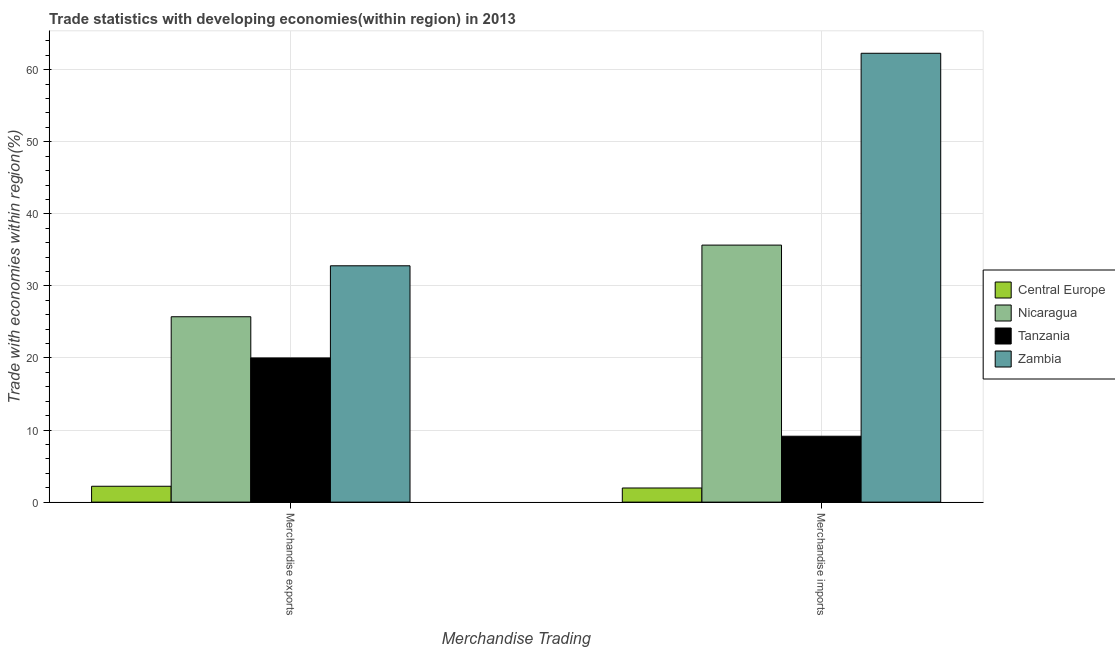Are the number of bars per tick equal to the number of legend labels?
Make the answer very short. Yes. How many bars are there on the 2nd tick from the right?
Your answer should be compact. 4. What is the label of the 2nd group of bars from the left?
Keep it short and to the point. Merchandise imports. What is the merchandise exports in Nicaragua?
Your response must be concise. 25.72. Across all countries, what is the maximum merchandise imports?
Keep it short and to the point. 62.28. Across all countries, what is the minimum merchandise imports?
Your answer should be compact. 1.96. In which country was the merchandise imports maximum?
Give a very brief answer. Zambia. In which country was the merchandise imports minimum?
Your response must be concise. Central Europe. What is the total merchandise exports in the graph?
Your response must be concise. 80.73. What is the difference between the merchandise imports in Nicaragua and that in Central Europe?
Offer a terse response. 33.7. What is the difference between the merchandise exports in Zambia and the merchandise imports in Nicaragua?
Offer a terse response. -2.87. What is the average merchandise exports per country?
Ensure brevity in your answer.  20.18. What is the difference between the merchandise imports and merchandise exports in Nicaragua?
Make the answer very short. 9.94. What is the ratio of the merchandise exports in Nicaragua to that in Tanzania?
Your response must be concise. 1.29. In how many countries, is the merchandise exports greater than the average merchandise exports taken over all countries?
Offer a very short reply. 2. What does the 2nd bar from the left in Merchandise imports represents?
Your answer should be very brief. Nicaragua. What does the 2nd bar from the right in Merchandise imports represents?
Your answer should be very brief. Tanzania. How many bars are there?
Your answer should be very brief. 8. Are all the bars in the graph horizontal?
Make the answer very short. No. Are the values on the major ticks of Y-axis written in scientific E-notation?
Offer a very short reply. No. Does the graph contain grids?
Make the answer very short. Yes. Where does the legend appear in the graph?
Provide a short and direct response. Center right. What is the title of the graph?
Give a very brief answer. Trade statistics with developing economies(within region) in 2013. Does "Cuba" appear as one of the legend labels in the graph?
Keep it short and to the point. No. What is the label or title of the X-axis?
Your answer should be very brief. Merchandise Trading. What is the label or title of the Y-axis?
Your answer should be very brief. Trade with economies within region(%). What is the Trade with economies within region(%) of Central Europe in Merchandise exports?
Ensure brevity in your answer.  2.2. What is the Trade with economies within region(%) in Nicaragua in Merchandise exports?
Provide a succinct answer. 25.72. What is the Trade with economies within region(%) in Tanzania in Merchandise exports?
Give a very brief answer. 20.01. What is the Trade with economies within region(%) of Zambia in Merchandise exports?
Ensure brevity in your answer.  32.8. What is the Trade with economies within region(%) in Central Europe in Merchandise imports?
Offer a terse response. 1.96. What is the Trade with economies within region(%) in Nicaragua in Merchandise imports?
Provide a succinct answer. 35.67. What is the Trade with economies within region(%) of Tanzania in Merchandise imports?
Your response must be concise. 9.15. What is the Trade with economies within region(%) in Zambia in Merchandise imports?
Provide a short and direct response. 62.28. Across all Merchandise Trading, what is the maximum Trade with economies within region(%) of Central Europe?
Ensure brevity in your answer.  2.2. Across all Merchandise Trading, what is the maximum Trade with economies within region(%) of Nicaragua?
Provide a short and direct response. 35.67. Across all Merchandise Trading, what is the maximum Trade with economies within region(%) of Tanzania?
Give a very brief answer. 20.01. Across all Merchandise Trading, what is the maximum Trade with economies within region(%) in Zambia?
Make the answer very short. 62.28. Across all Merchandise Trading, what is the minimum Trade with economies within region(%) of Central Europe?
Ensure brevity in your answer.  1.96. Across all Merchandise Trading, what is the minimum Trade with economies within region(%) in Nicaragua?
Your answer should be compact. 25.72. Across all Merchandise Trading, what is the minimum Trade with economies within region(%) of Tanzania?
Your response must be concise. 9.15. Across all Merchandise Trading, what is the minimum Trade with economies within region(%) of Zambia?
Make the answer very short. 32.8. What is the total Trade with economies within region(%) of Central Europe in the graph?
Offer a very short reply. 4.16. What is the total Trade with economies within region(%) in Nicaragua in the graph?
Offer a very short reply. 61.39. What is the total Trade with economies within region(%) of Tanzania in the graph?
Offer a terse response. 29.15. What is the total Trade with economies within region(%) of Zambia in the graph?
Your response must be concise. 95.08. What is the difference between the Trade with economies within region(%) in Central Europe in Merchandise exports and that in Merchandise imports?
Your response must be concise. 0.24. What is the difference between the Trade with economies within region(%) in Nicaragua in Merchandise exports and that in Merchandise imports?
Your response must be concise. -9.94. What is the difference between the Trade with economies within region(%) of Tanzania in Merchandise exports and that in Merchandise imports?
Make the answer very short. 10.86. What is the difference between the Trade with economies within region(%) in Zambia in Merchandise exports and that in Merchandise imports?
Your answer should be very brief. -29.49. What is the difference between the Trade with economies within region(%) of Central Europe in Merchandise exports and the Trade with economies within region(%) of Nicaragua in Merchandise imports?
Provide a succinct answer. -33.46. What is the difference between the Trade with economies within region(%) of Central Europe in Merchandise exports and the Trade with economies within region(%) of Tanzania in Merchandise imports?
Offer a terse response. -6.94. What is the difference between the Trade with economies within region(%) of Central Europe in Merchandise exports and the Trade with economies within region(%) of Zambia in Merchandise imports?
Provide a succinct answer. -60.08. What is the difference between the Trade with economies within region(%) in Nicaragua in Merchandise exports and the Trade with economies within region(%) in Tanzania in Merchandise imports?
Offer a very short reply. 16.58. What is the difference between the Trade with economies within region(%) of Nicaragua in Merchandise exports and the Trade with economies within region(%) of Zambia in Merchandise imports?
Ensure brevity in your answer.  -36.56. What is the difference between the Trade with economies within region(%) in Tanzania in Merchandise exports and the Trade with economies within region(%) in Zambia in Merchandise imports?
Provide a succinct answer. -42.27. What is the average Trade with economies within region(%) of Central Europe per Merchandise Trading?
Offer a very short reply. 2.08. What is the average Trade with economies within region(%) of Nicaragua per Merchandise Trading?
Your answer should be compact. 30.69. What is the average Trade with economies within region(%) in Tanzania per Merchandise Trading?
Offer a terse response. 14.58. What is the average Trade with economies within region(%) of Zambia per Merchandise Trading?
Offer a terse response. 47.54. What is the difference between the Trade with economies within region(%) in Central Europe and Trade with economies within region(%) in Nicaragua in Merchandise exports?
Make the answer very short. -23.52. What is the difference between the Trade with economies within region(%) of Central Europe and Trade with economies within region(%) of Tanzania in Merchandise exports?
Provide a succinct answer. -17.81. What is the difference between the Trade with economies within region(%) of Central Europe and Trade with economies within region(%) of Zambia in Merchandise exports?
Offer a very short reply. -30.59. What is the difference between the Trade with economies within region(%) of Nicaragua and Trade with economies within region(%) of Tanzania in Merchandise exports?
Your answer should be compact. 5.71. What is the difference between the Trade with economies within region(%) in Nicaragua and Trade with economies within region(%) in Zambia in Merchandise exports?
Keep it short and to the point. -7.07. What is the difference between the Trade with economies within region(%) of Tanzania and Trade with economies within region(%) of Zambia in Merchandise exports?
Provide a short and direct response. -12.79. What is the difference between the Trade with economies within region(%) of Central Europe and Trade with economies within region(%) of Nicaragua in Merchandise imports?
Make the answer very short. -33.7. What is the difference between the Trade with economies within region(%) in Central Europe and Trade with economies within region(%) in Tanzania in Merchandise imports?
Provide a succinct answer. -7.18. What is the difference between the Trade with economies within region(%) in Central Europe and Trade with economies within region(%) in Zambia in Merchandise imports?
Make the answer very short. -60.32. What is the difference between the Trade with economies within region(%) of Nicaragua and Trade with economies within region(%) of Tanzania in Merchandise imports?
Provide a succinct answer. 26.52. What is the difference between the Trade with economies within region(%) of Nicaragua and Trade with economies within region(%) of Zambia in Merchandise imports?
Your answer should be compact. -26.62. What is the difference between the Trade with economies within region(%) in Tanzania and Trade with economies within region(%) in Zambia in Merchandise imports?
Offer a very short reply. -53.14. What is the ratio of the Trade with economies within region(%) in Central Europe in Merchandise exports to that in Merchandise imports?
Ensure brevity in your answer.  1.12. What is the ratio of the Trade with economies within region(%) of Nicaragua in Merchandise exports to that in Merchandise imports?
Provide a succinct answer. 0.72. What is the ratio of the Trade with economies within region(%) in Tanzania in Merchandise exports to that in Merchandise imports?
Your response must be concise. 2.19. What is the ratio of the Trade with economies within region(%) of Zambia in Merchandise exports to that in Merchandise imports?
Make the answer very short. 0.53. What is the difference between the highest and the second highest Trade with economies within region(%) in Central Europe?
Your answer should be very brief. 0.24. What is the difference between the highest and the second highest Trade with economies within region(%) in Nicaragua?
Make the answer very short. 9.94. What is the difference between the highest and the second highest Trade with economies within region(%) of Tanzania?
Your answer should be very brief. 10.86. What is the difference between the highest and the second highest Trade with economies within region(%) in Zambia?
Provide a succinct answer. 29.49. What is the difference between the highest and the lowest Trade with economies within region(%) of Central Europe?
Provide a succinct answer. 0.24. What is the difference between the highest and the lowest Trade with economies within region(%) of Nicaragua?
Give a very brief answer. 9.94. What is the difference between the highest and the lowest Trade with economies within region(%) in Tanzania?
Ensure brevity in your answer.  10.86. What is the difference between the highest and the lowest Trade with economies within region(%) in Zambia?
Give a very brief answer. 29.49. 